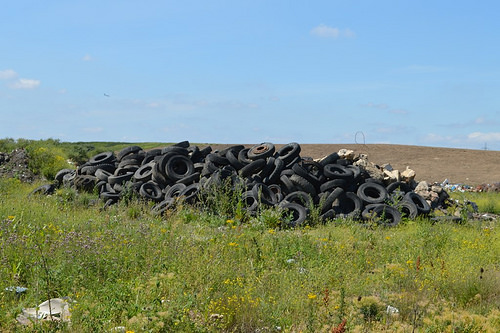<image>
Is there a tire on the dirt? No. The tire is not positioned on the dirt. They may be near each other, but the tire is not supported by or resting on top of the dirt. 